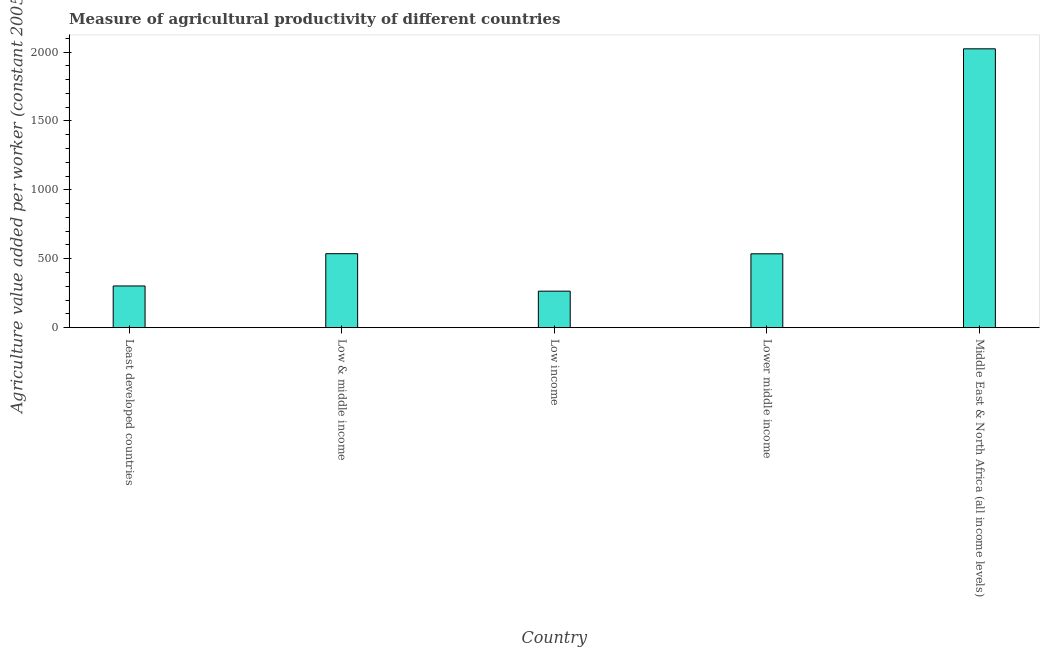What is the title of the graph?
Offer a terse response. Measure of agricultural productivity of different countries. What is the label or title of the X-axis?
Offer a very short reply. Country. What is the label or title of the Y-axis?
Ensure brevity in your answer.  Agriculture value added per worker (constant 2005 US$). What is the agriculture value added per worker in Lower middle income?
Offer a very short reply. 536.04. Across all countries, what is the maximum agriculture value added per worker?
Your answer should be very brief. 2023.9. Across all countries, what is the minimum agriculture value added per worker?
Your response must be concise. 264.94. In which country was the agriculture value added per worker maximum?
Ensure brevity in your answer.  Middle East & North Africa (all income levels). In which country was the agriculture value added per worker minimum?
Provide a succinct answer. Low income. What is the sum of the agriculture value added per worker?
Ensure brevity in your answer.  3664.49. What is the difference between the agriculture value added per worker in Low income and Middle East & North Africa (all income levels)?
Your response must be concise. -1758.96. What is the average agriculture value added per worker per country?
Give a very brief answer. 732.9. What is the median agriculture value added per worker?
Give a very brief answer. 536.04. What is the ratio of the agriculture value added per worker in Low & middle income to that in Lower middle income?
Give a very brief answer. 1. Is the agriculture value added per worker in Low & middle income less than that in Low income?
Offer a very short reply. No. Is the difference between the agriculture value added per worker in Low income and Lower middle income greater than the difference between any two countries?
Ensure brevity in your answer.  No. What is the difference between the highest and the second highest agriculture value added per worker?
Provide a succinct answer. 1487.03. Is the sum of the agriculture value added per worker in Low & middle income and Low income greater than the maximum agriculture value added per worker across all countries?
Provide a succinct answer. No. What is the difference between the highest and the lowest agriculture value added per worker?
Provide a short and direct response. 1758.96. Are all the bars in the graph horizontal?
Ensure brevity in your answer.  No. How many countries are there in the graph?
Provide a succinct answer. 5. What is the Agriculture value added per worker (constant 2005 US$) in Least developed countries?
Give a very brief answer. 302.73. What is the Agriculture value added per worker (constant 2005 US$) of Low & middle income?
Give a very brief answer. 536.88. What is the Agriculture value added per worker (constant 2005 US$) of Low income?
Provide a short and direct response. 264.94. What is the Agriculture value added per worker (constant 2005 US$) of Lower middle income?
Your answer should be compact. 536.04. What is the Agriculture value added per worker (constant 2005 US$) in Middle East & North Africa (all income levels)?
Provide a succinct answer. 2023.9. What is the difference between the Agriculture value added per worker (constant 2005 US$) in Least developed countries and Low & middle income?
Your answer should be compact. -234.15. What is the difference between the Agriculture value added per worker (constant 2005 US$) in Least developed countries and Low income?
Provide a succinct answer. 37.78. What is the difference between the Agriculture value added per worker (constant 2005 US$) in Least developed countries and Lower middle income?
Give a very brief answer. -233.32. What is the difference between the Agriculture value added per worker (constant 2005 US$) in Least developed countries and Middle East & North Africa (all income levels)?
Provide a short and direct response. -1721.18. What is the difference between the Agriculture value added per worker (constant 2005 US$) in Low & middle income and Low income?
Give a very brief answer. 271.93. What is the difference between the Agriculture value added per worker (constant 2005 US$) in Low & middle income and Lower middle income?
Give a very brief answer. 0.83. What is the difference between the Agriculture value added per worker (constant 2005 US$) in Low & middle income and Middle East & North Africa (all income levels)?
Your answer should be compact. -1487.03. What is the difference between the Agriculture value added per worker (constant 2005 US$) in Low income and Lower middle income?
Your response must be concise. -271.1. What is the difference between the Agriculture value added per worker (constant 2005 US$) in Low income and Middle East & North Africa (all income levels)?
Offer a very short reply. -1758.96. What is the difference between the Agriculture value added per worker (constant 2005 US$) in Lower middle income and Middle East & North Africa (all income levels)?
Your answer should be compact. -1487.86. What is the ratio of the Agriculture value added per worker (constant 2005 US$) in Least developed countries to that in Low & middle income?
Your answer should be very brief. 0.56. What is the ratio of the Agriculture value added per worker (constant 2005 US$) in Least developed countries to that in Low income?
Keep it short and to the point. 1.14. What is the ratio of the Agriculture value added per worker (constant 2005 US$) in Least developed countries to that in Lower middle income?
Your answer should be compact. 0.56. What is the ratio of the Agriculture value added per worker (constant 2005 US$) in Low & middle income to that in Low income?
Ensure brevity in your answer.  2.03. What is the ratio of the Agriculture value added per worker (constant 2005 US$) in Low & middle income to that in Lower middle income?
Offer a terse response. 1. What is the ratio of the Agriculture value added per worker (constant 2005 US$) in Low & middle income to that in Middle East & North Africa (all income levels)?
Ensure brevity in your answer.  0.27. What is the ratio of the Agriculture value added per worker (constant 2005 US$) in Low income to that in Lower middle income?
Provide a short and direct response. 0.49. What is the ratio of the Agriculture value added per worker (constant 2005 US$) in Low income to that in Middle East & North Africa (all income levels)?
Your response must be concise. 0.13. What is the ratio of the Agriculture value added per worker (constant 2005 US$) in Lower middle income to that in Middle East & North Africa (all income levels)?
Make the answer very short. 0.27. 